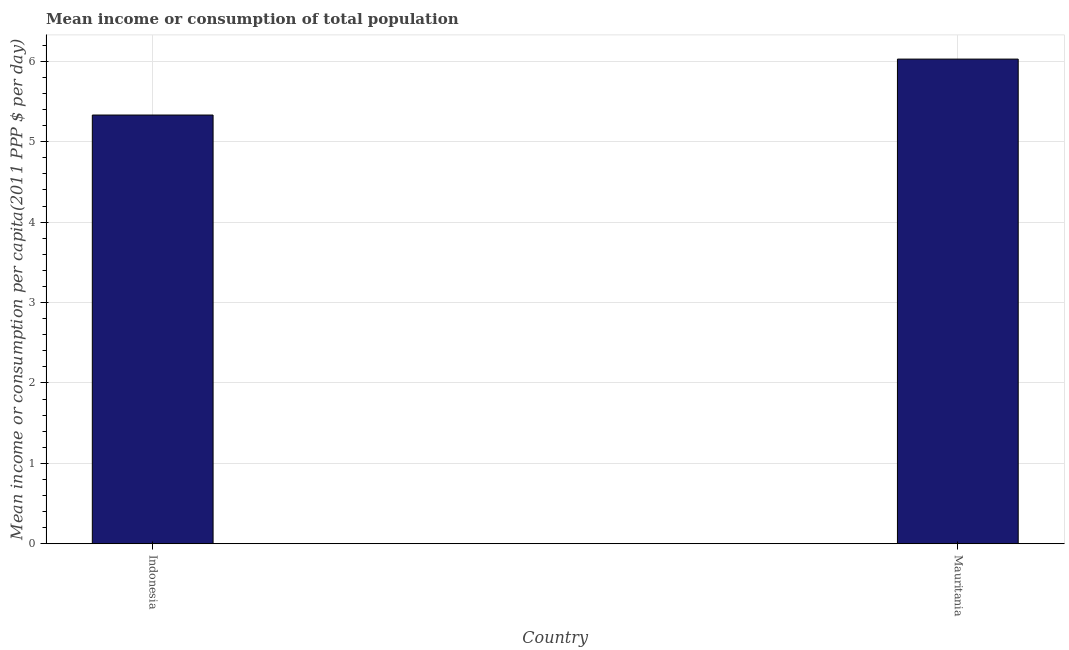Does the graph contain grids?
Your answer should be compact. Yes. What is the title of the graph?
Give a very brief answer. Mean income or consumption of total population. What is the label or title of the X-axis?
Provide a succinct answer. Country. What is the label or title of the Y-axis?
Offer a terse response. Mean income or consumption per capita(2011 PPP $ per day). What is the mean income or consumption in Indonesia?
Provide a short and direct response. 5.33. Across all countries, what is the maximum mean income or consumption?
Give a very brief answer. 6.03. Across all countries, what is the minimum mean income or consumption?
Ensure brevity in your answer.  5.33. In which country was the mean income or consumption maximum?
Provide a succinct answer. Mauritania. In which country was the mean income or consumption minimum?
Your response must be concise. Indonesia. What is the sum of the mean income or consumption?
Your answer should be very brief. 11.36. What is the difference between the mean income or consumption in Indonesia and Mauritania?
Ensure brevity in your answer.  -0.7. What is the average mean income or consumption per country?
Offer a terse response. 5.68. What is the median mean income or consumption?
Offer a terse response. 5.68. What is the ratio of the mean income or consumption in Indonesia to that in Mauritania?
Offer a terse response. 0.89. Is the mean income or consumption in Indonesia less than that in Mauritania?
Keep it short and to the point. Yes. In how many countries, is the mean income or consumption greater than the average mean income or consumption taken over all countries?
Provide a short and direct response. 1. How many countries are there in the graph?
Make the answer very short. 2. Are the values on the major ticks of Y-axis written in scientific E-notation?
Provide a short and direct response. No. What is the Mean income or consumption per capita(2011 PPP $ per day) in Indonesia?
Keep it short and to the point. 5.33. What is the Mean income or consumption per capita(2011 PPP $ per day) of Mauritania?
Provide a short and direct response. 6.03. What is the difference between the Mean income or consumption per capita(2011 PPP $ per day) in Indonesia and Mauritania?
Your answer should be compact. -0.7. What is the ratio of the Mean income or consumption per capita(2011 PPP $ per day) in Indonesia to that in Mauritania?
Make the answer very short. 0.89. 